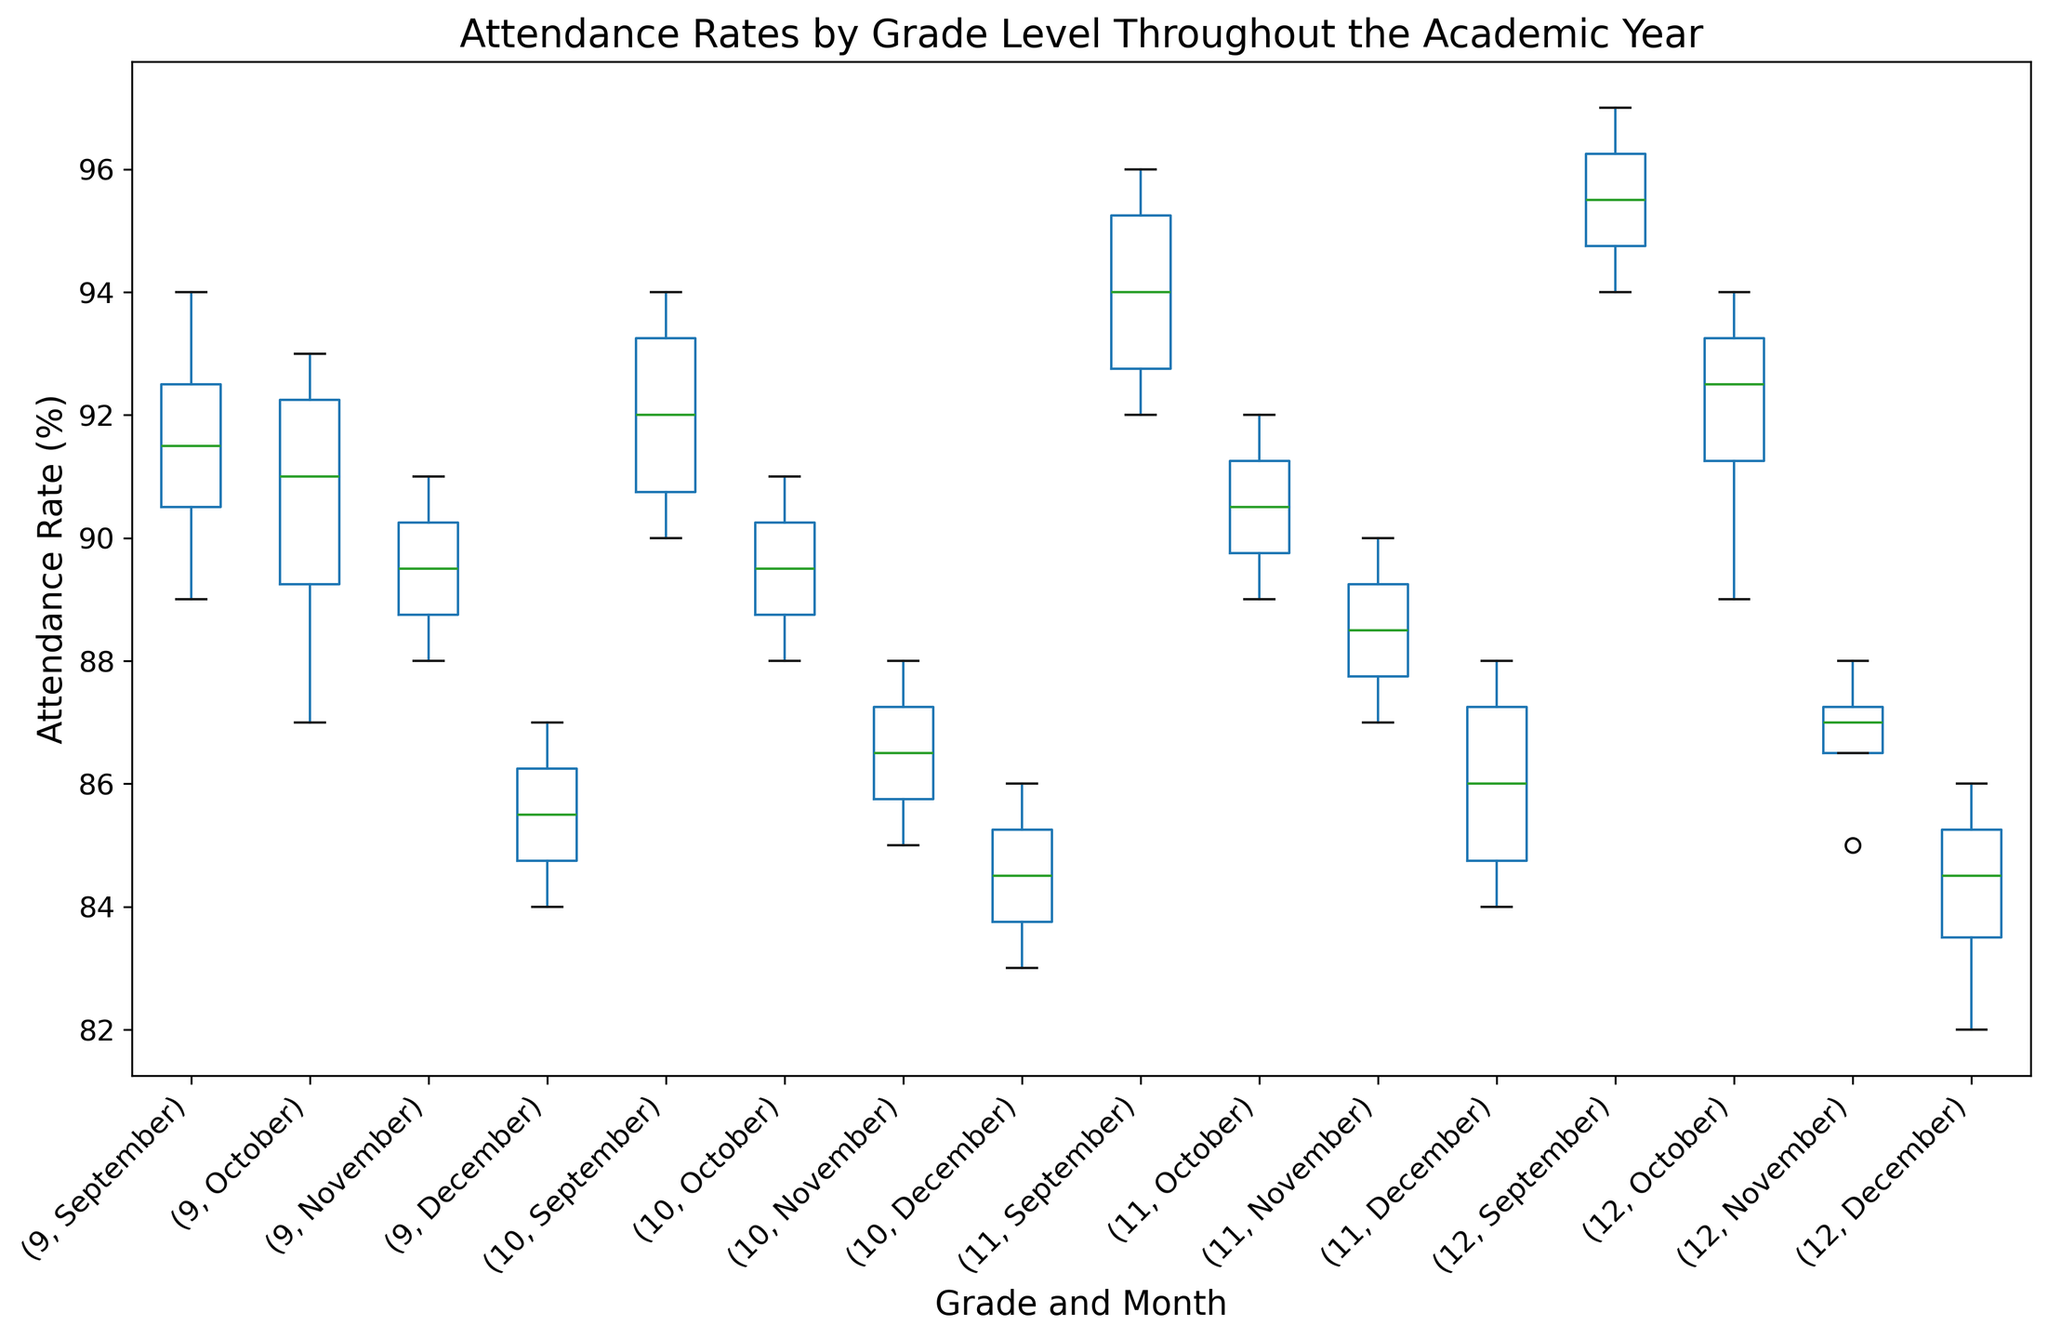What is the range of attendance rates for 9th grade in September? To find the range, subtract the minimum attendance rate from the maximum attendance rate for the 9th grade in September. From the box plot, identify the smallest and largest values (e.g., min = 89, max = 94). Range = 94 - 89.
Answer: 5 How does the median attendance rate of 10th grade in October compare to that in December? Locate the median (the line inside the box) for both October and December for 10th grade. Observe their values (e.g., October median ≈ 89.5 and December median ≈ 84.5). Then compare these values.
Answer: Higher in October Which grade and month have the widest interquartile range (IQR) for attendance rates? The IQR is the difference between the upper quartile (75th percentile) and the lower quartile (25th percentile). Identify the grade and month where the box (representing the IQR) is the widest.
Answer: 12th grade in September Is the average attendance rate for 11th grade in December higher or lower than the median rate for 12th grade in November? First, estimate the average attendance rate for all data points for the 11th grade in December using the box plot. Then, find the median value line for the 12th grade in November. Compare these two values.
Answer: Lower By how much does the median attendance rate in September differ between grades 9 and 12? Find the median attendance rates for 9th and 12th grades in September by looking at the line inside the boxes for each grade and month. For example, if the median for 9th grade is 91.5 and for 12th grade is 95.5, then compute the difference: 95.5 - 91.5.
Answer: 4 In which grade and month does the minimum attendance rate occur? Look for the lowest point (whisker or outlier) across all box plots in different grades and months to identify the minimum attendance rate.
Answer: 12th grade in December Compare the upper quartile of 11th grade in November to the lower quartile of 10th grade in September. Which is greater? Identify the upper quartile for 11th grade in November and the lower quartile for 10th grade in September on the box plot. Compare these values to determine which one is higher.
Answer: Upper quartile of 11th grade in November Which month shows the largest drop in median attendance rate for 10th grade from the previous month? Find the median attendance rates for 10th grade across all months and calculate the month-to-month difference to determine the largest decrease. The largest change will show the month with the greatest drop.
Answer: November 